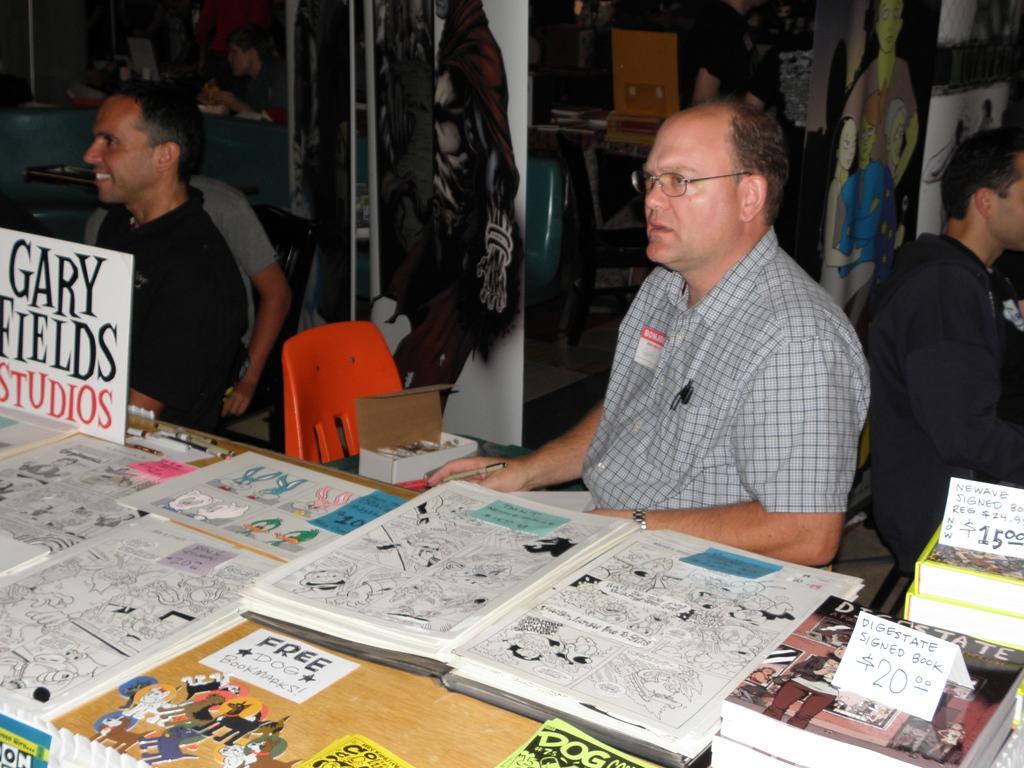Provide a one-sentence caption for the provided image. Two men sit at a table and one has a sign with Gary Field Studios in front of him. 